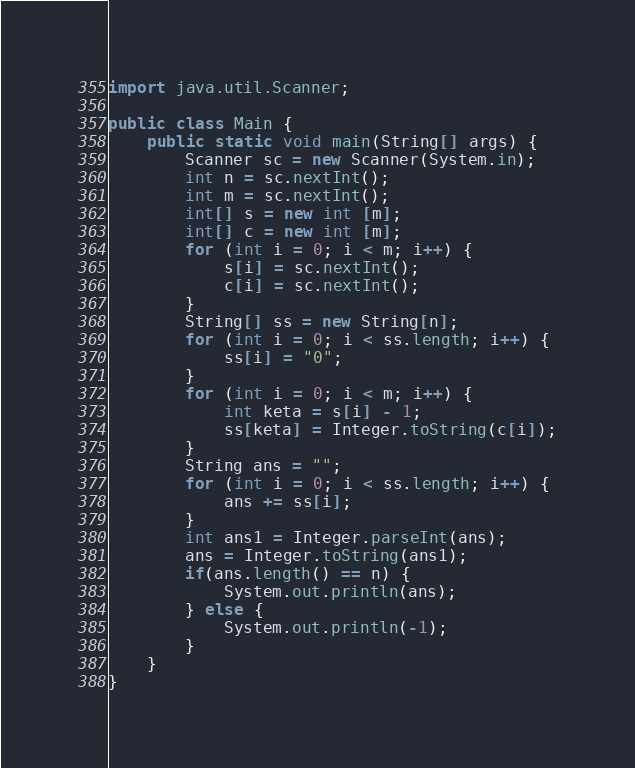<code> <loc_0><loc_0><loc_500><loc_500><_Java_>import java.util.Scanner;

public class Main {
    public static void main(String[] args) {
        Scanner sc = new Scanner(System.in);
        int n = sc.nextInt();
        int m = sc.nextInt();
        int[] s = new int [m];
        int[] c = new int [m];
        for (int i = 0; i < m; i++) {
            s[i] = sc.nextInt();
            c[i] = sc.nextInt();
        }
        String[] ss = new String[n];
        for (int i = 0; i < ss.length; i++) {
            ss[i] = "0";
        }
        for (int i = 0; i < m; i++) {
            int keta = s[i] - 1;
            ss[keta] = Integer.toString(c[i]);
        }
        String ans = "";
        for (int i = 0; i < ss.length; i++) {
            ans += ss[i];
        }
        int ans1 = Integer.parseInt(ans);
        ans = Integer.toString(ans1);
        if(ans.length() == n) {
            System.out.println(ans);
        } else {
            System.out.println(-1);
        }
    }
}</code> 